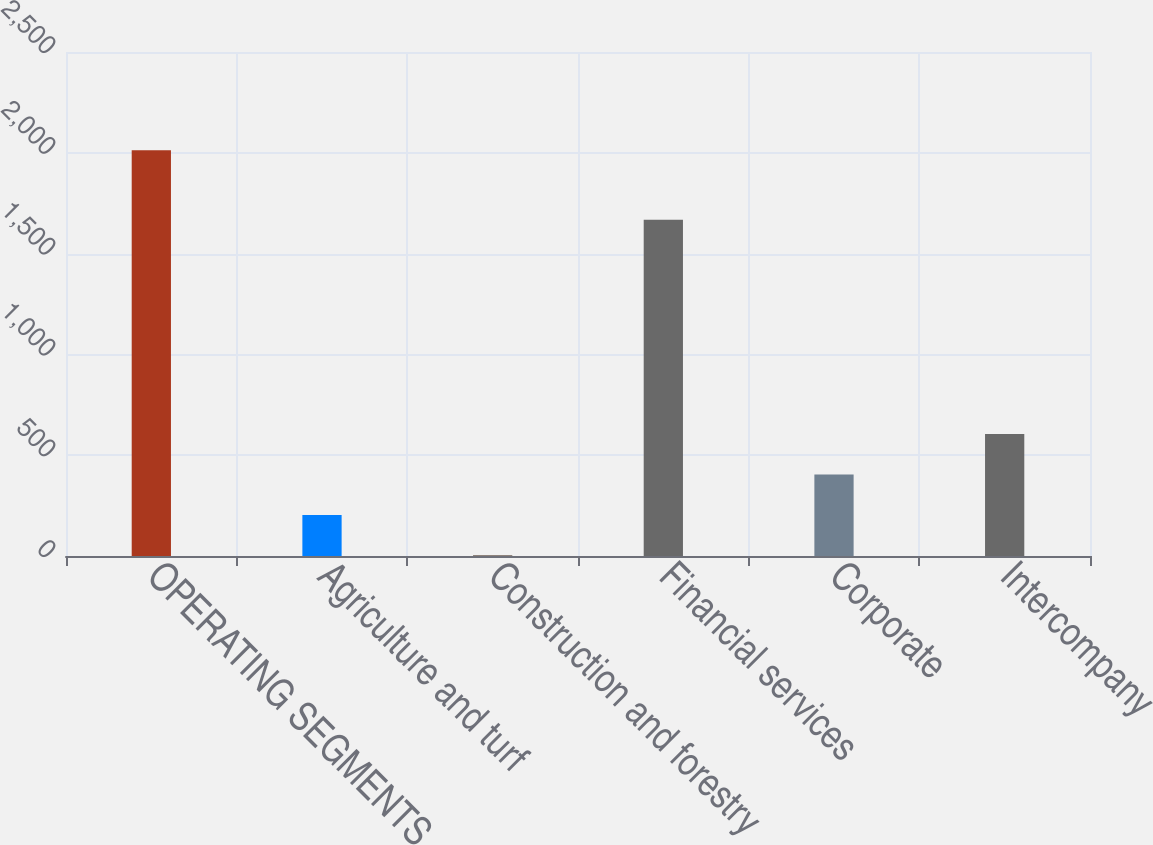Convert chart. <chart><loc_0><loc_0><loc_500><loc_500><bar_chart><fcel>OPERATING SEGMENTS<fcel>Agriculture and turf<fcel>Construction and forestry<fcel>Financial services<fcel>Corporate<fcel>Intercompany<nl><fcel>2013<fcel>203.1<fcel>2<fcel>1668<fcel>404.2<fcel>605.3<nl></chart> 